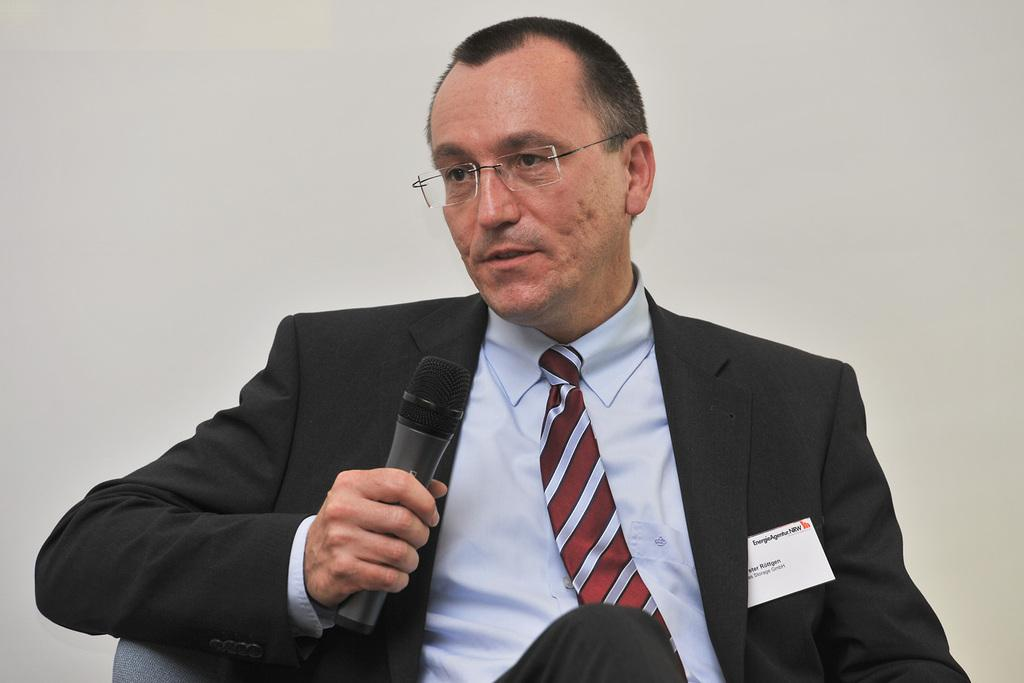Who is present in the image? There is a man in the image. What is the man doing in the image? The man is sitting in a chair and talking into a microphone. What type of clothing is the man wearing? The man is wearing a tie and a shirt. Where is the girl playing with a bottle in the cemetery in the image? There is no girl, bottle, or cemetery present in the image; it features a man sitting in a chair and talking into a microphone. 